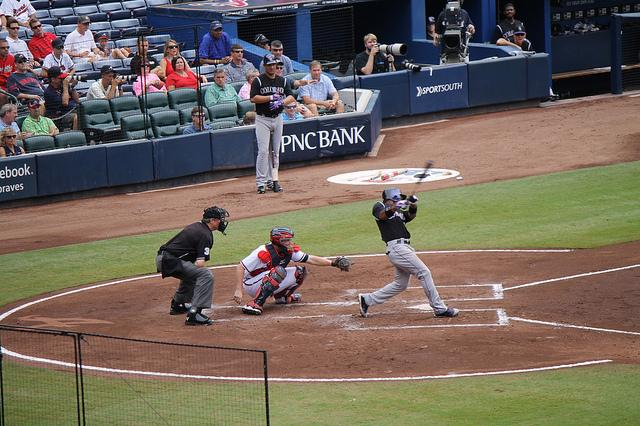Who is an all-time legend for one of these teams? Please explain your reasoning. todd helton. The legend is helton. 